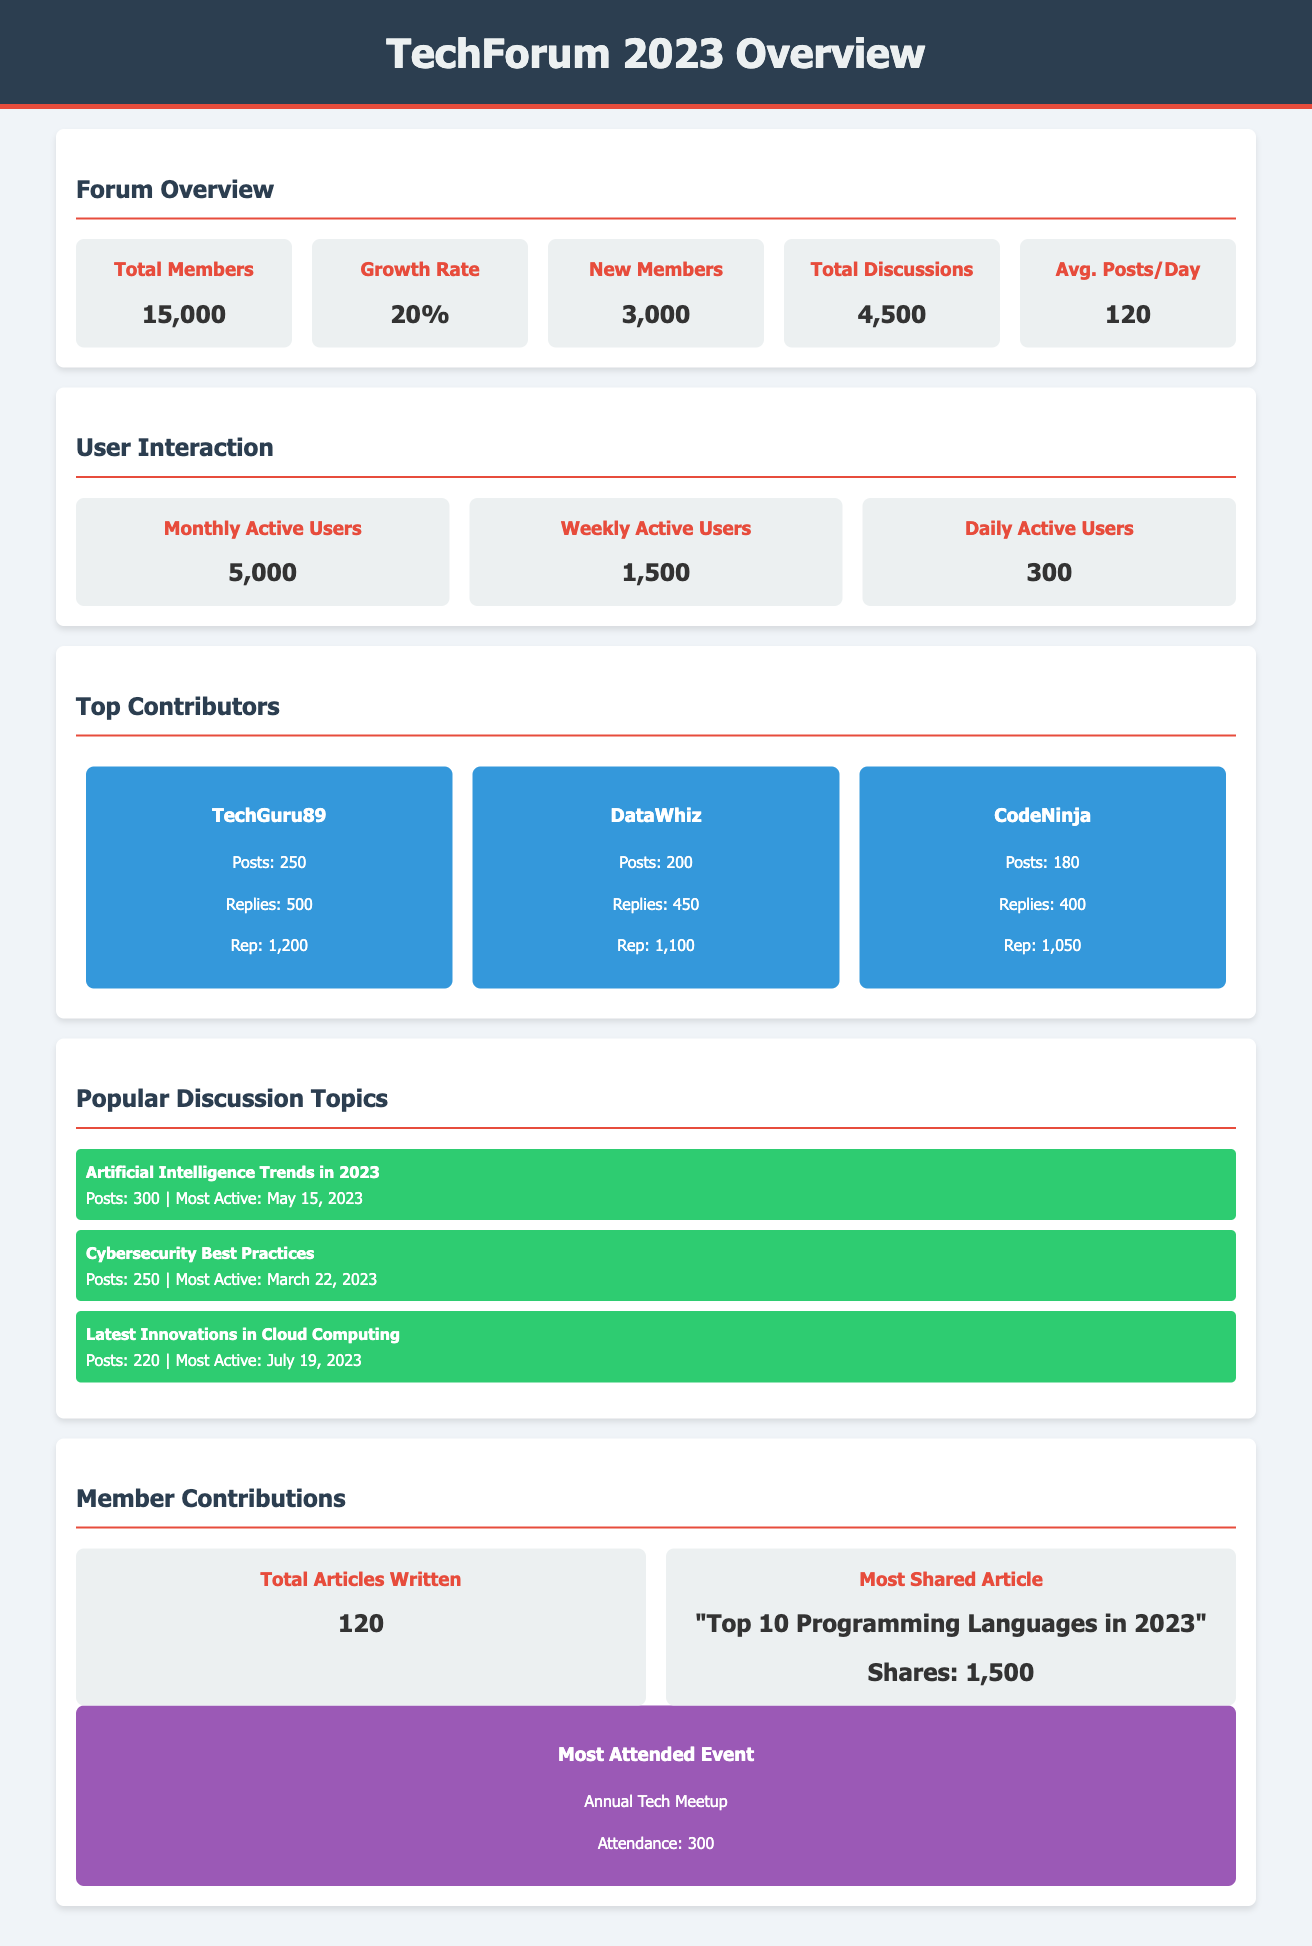What is the total number of members? The total number of members is clearly stated in the document as 15,000.
Answer: 15,000 What is the growth rate of the forum community? The growth rate of the forum community is mentioned as 20%.
Answer: 20% How many new members joined in 2023? The document specifies that 3,000 new members joined the forum in 2023.
Answer: 3,000 What is the average number of posts per day? The average number of posts per day is provided as 120 in the document.
Answer: 120 Who is the top contributor with the most posts? The document lists TechGuru89 as the top contributor with 250 posts.
Answer: TechGuru89 Which discussion topic had the most posts? The discussion topic "Artificial Intelligence Trends in 2023" had the most posts, totaling 300.
Answer: Artificial Intelligence Trends in 2023 What is the title of the most shared article? The document mentions "Top 10 Programming Languages in 2023" as the most shared article.
Answer: Top 10 Programming Languages in 2023 How many attendees were at the most attended event? The document states that the most attended event, the Annual Tech Meetup, had 300 attendees.
Answer: 300 How many total discussions were there in 2023? The total number of discussions recorded in the document is 4,500.
Answer: 4,500 